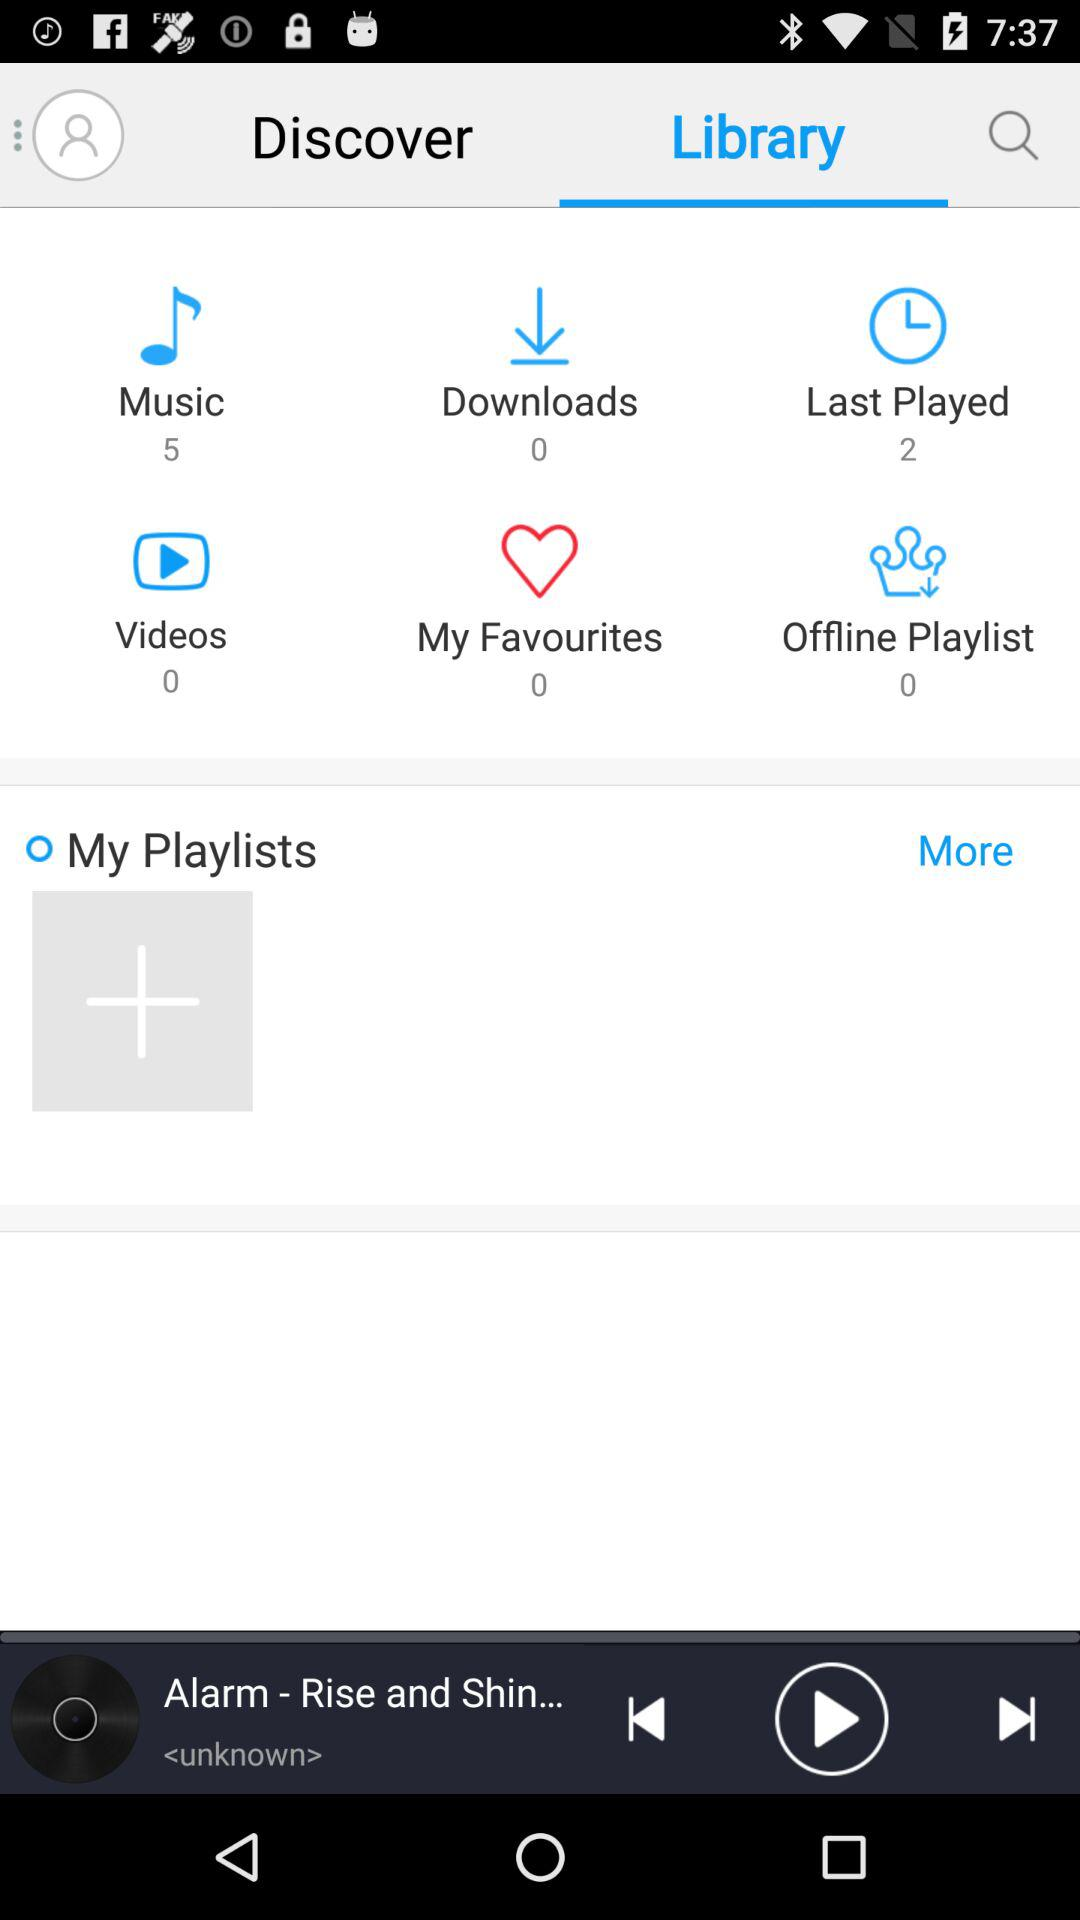What is the number of music? The number of music is 5. 